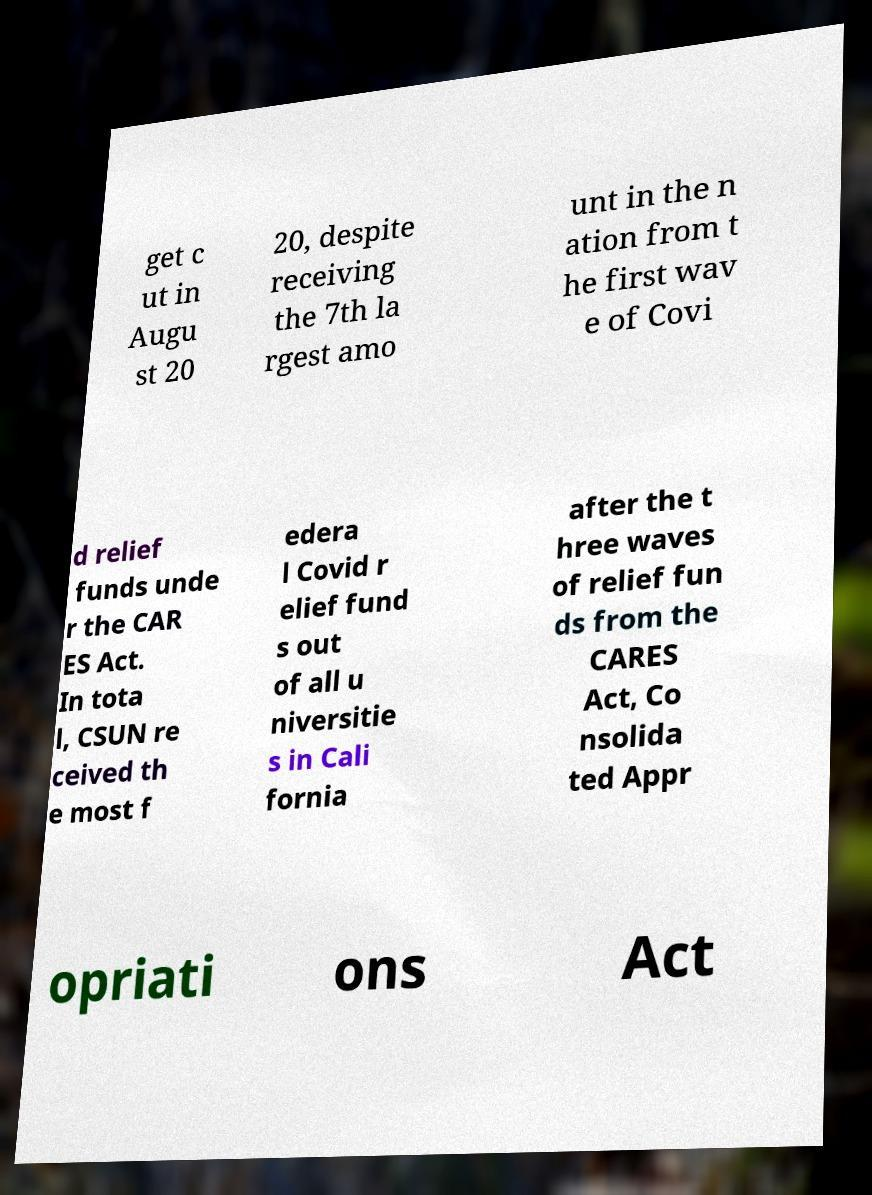What messages or text are displayed in this image? I need them in a readable, typed format. get c ut in Augu st 20 20, despite receiving the 7th la rgest amo unt in the n ation from t he first wav e of Covi d relief funds unde r the CAR ES Act. In tota l, CSUN re ceived th e most f edera l Covid r elief fund s out of all u niversitie s in Cali fornia after the t hree waves of relief fun ds from the CARES Act, Co nsolida ted Appr opriati ons Act 